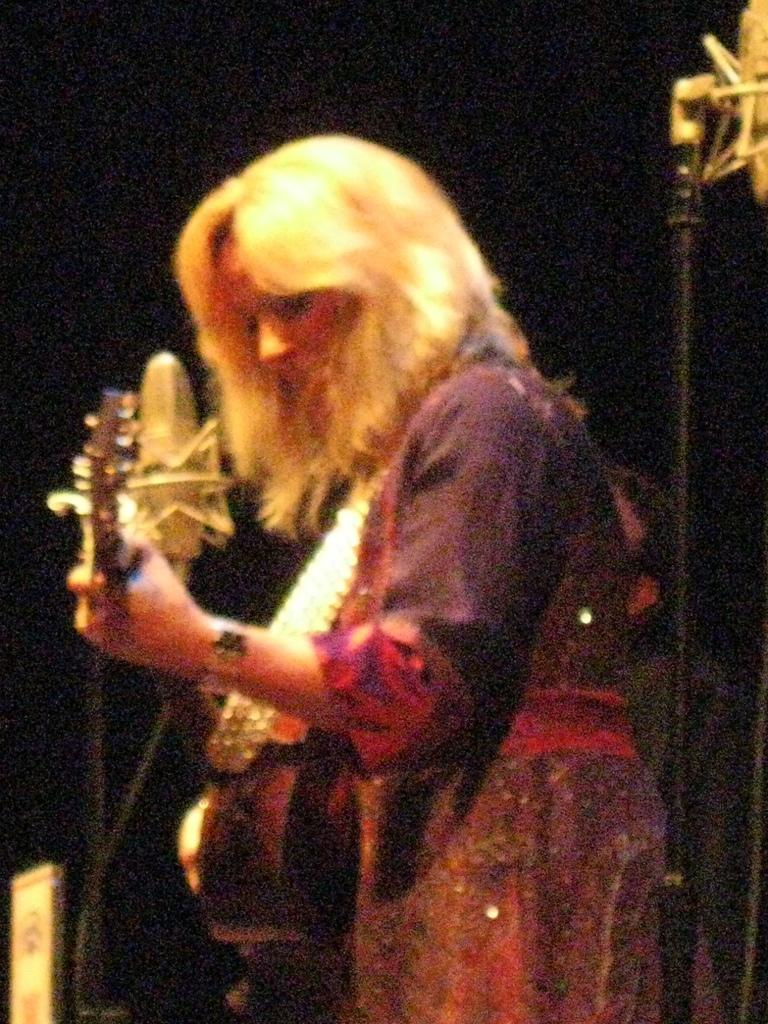What is the woman in the image holding? The woman is holding a guitar. What objects are present in the image that might be used for amplifying sound? There are microphones with stands in the image. How would you describe the lighting in the image? The background of the image is dark. What type of muscle is being exercised by the woman in the image? There is no indication of exercise or muscle activity in the image; the woman is simply holding a guitar. What is the profit margin for the concert depicted in the image? There is no information about a concert or profit in the image; it only shows a woman holding a guitar and microphones with stands. 